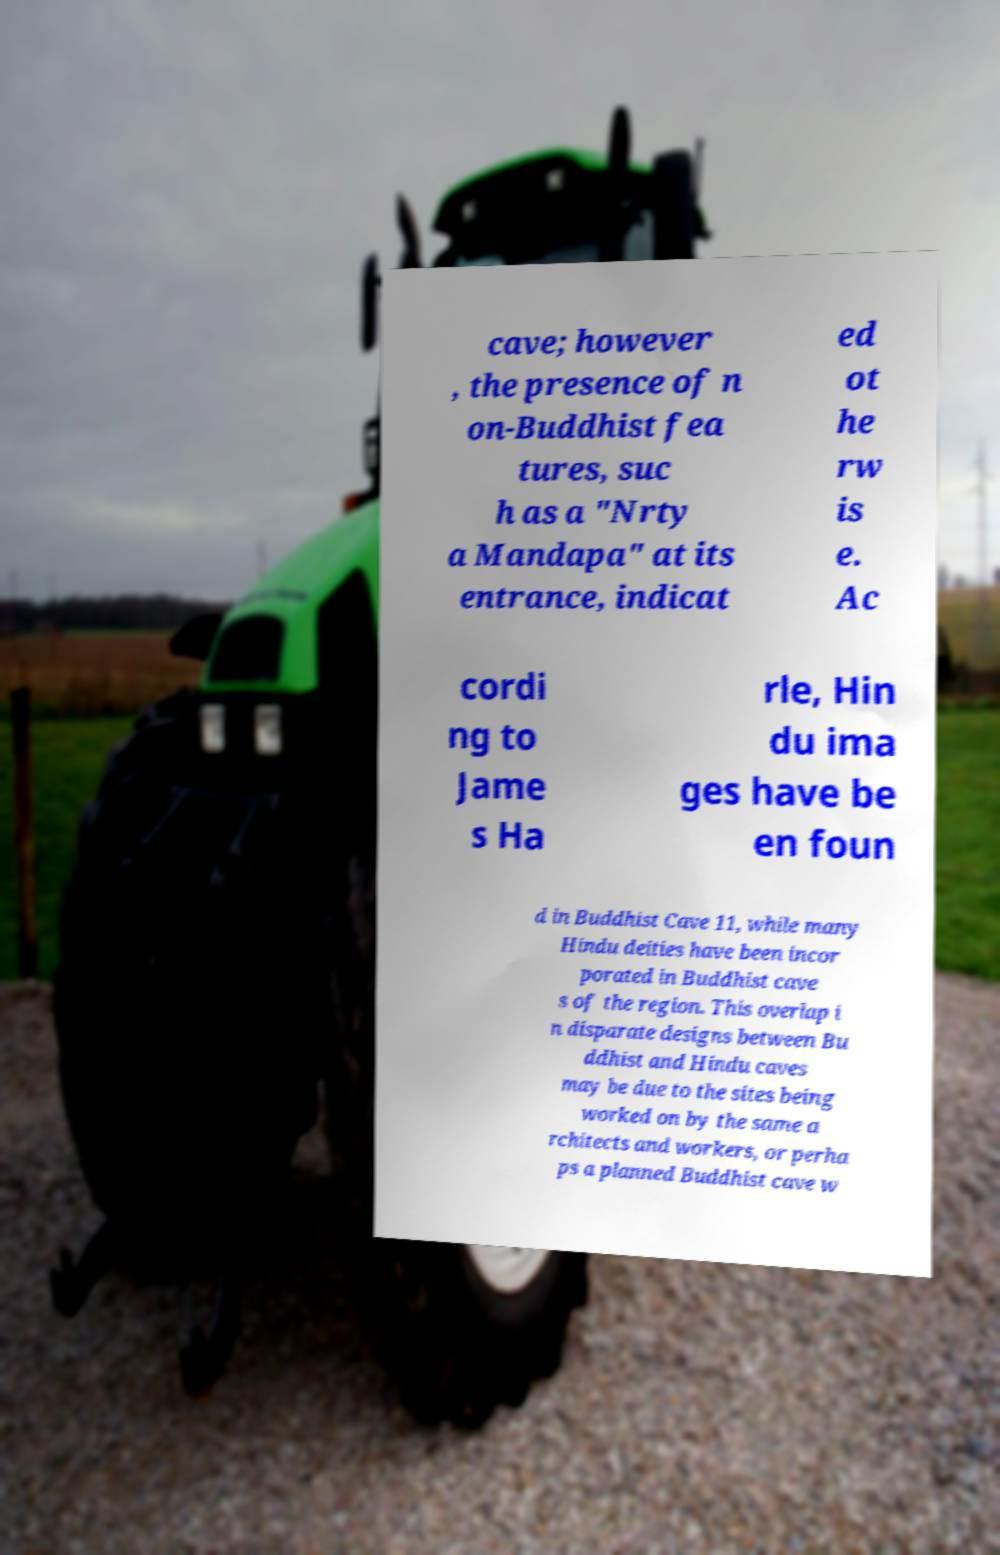Can you accurately transcribe the text from the provided image for me? cave; however , the presence of n on-Buddhist fea tures, suc h as a "Nrty a Mandapa" at its entrance, indicat ed ot he rw is e. Ac cordi ng to Jame s Ha rle, Hin du ima ges have be en foun d in Buddhist Cave 11, while many Hindu deities have been incor porated in Buddhist cave s of the region. This overlap i n disparate designs between Bu ddhist and Hindu caves may be due to the sites being worked on by the same a rchitects and workers, or perha ps a planned Buddhist cave w 